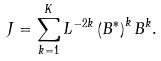<formula> <loc_0><loc_0><loc_500><loc_500>J = \sum _ { k = 1 } ^ { K } L ^ { - 2 k } \left ( B ^ { \ast } \right ) ^ { k } B ^ { k } .</formula> 